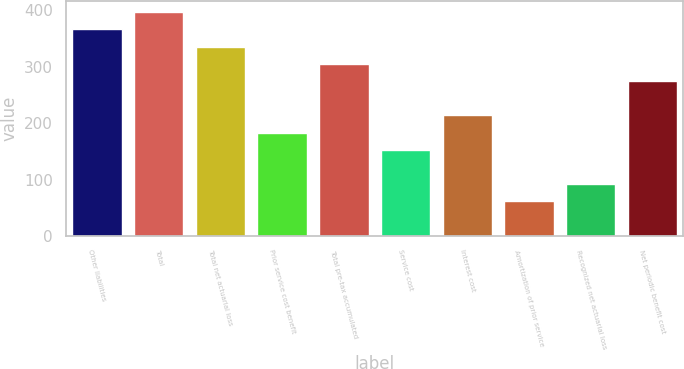<chart> <loc_0><loc_0><loc_500><loc_500><bar_chart><fcel>Other liabilities<fcel>Total<fcel>Total net actuarial loss<fcel>Prior service cost benefit<fcel>Total pre-tax accumulated<fcel>Service cost<fcel>Interest cost<fcel>Amortization of prior service<fcel>Recognized net actuarial loss<fcel>Net periodic benefit cost<nl><fcel>366.26<fcel>396.74<fcel>335.78<fcel>183.38<fcel>305.3<fcel>152.9<fcel>213.86<fcel>61.46<fcel>91.94<fcel>274.82<nl></chart> 